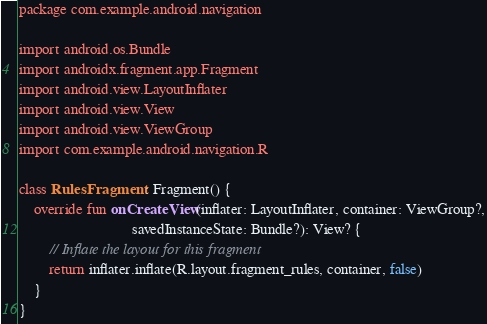<code> <loc_0><loc_0><loc_500><loc_500><_Kotlin_>package com.example.android.navigation

import android.os.Bundle
import androidx.fragment.app.Fragment
import android.view.LayoutInflater
import android.view.View
import android.view.ViewGroup
import com.example.android.navigation.R

class RulesFragment : Fragment() {
    override fun onCreateView(inflater: LayoutInflater, container: ViewGroup?,
                              savedInstanceState: Bundle?): View? {
        // Inflate the layout for this fragment
        return inflater.inflate(R.layout.fragment_rules, container, false)
    }
}
</code> 